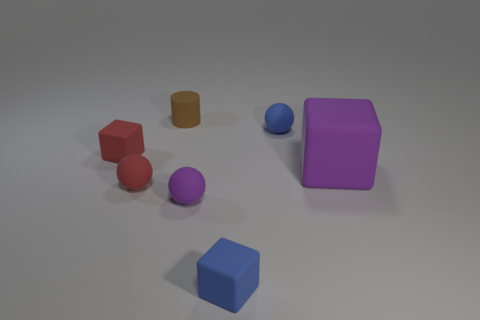How many things are in front of the red matte cube?
Provide a short and direct response. 4. There is a red rubber thing that is the same shape as the tiny purple object; what is its size?
Make the answer very short. Small. There is a rubber object that is left of the tiny matte cylinder and behind the purple rubber block; how big is it?
Offer a very short reply. Small. There is a small cylinder; does it have the same color as the small rubber ball that is on the left side of the brown rubber cylinder?
Offer a very short reply. No. What number of red things are small cylinders or tiny matte cubes?
Your answer should be compact. 1. The small purple matte object has what shape?
Make the answer very short. Sphere. What number of other objects are the same shape as the tiny brown matte thing?
Your response must be concise. 0. The thing behind the blue matte ball is what color?
Give a very brief answer. Brown. Is the brown thing made of the same material as the small red ball?
Ensure brevity in your answer.  Yes. How many things are small blue blocks or matte cubes that are behind the tiny purple matte object?
Provide a short and direct response. 3. 